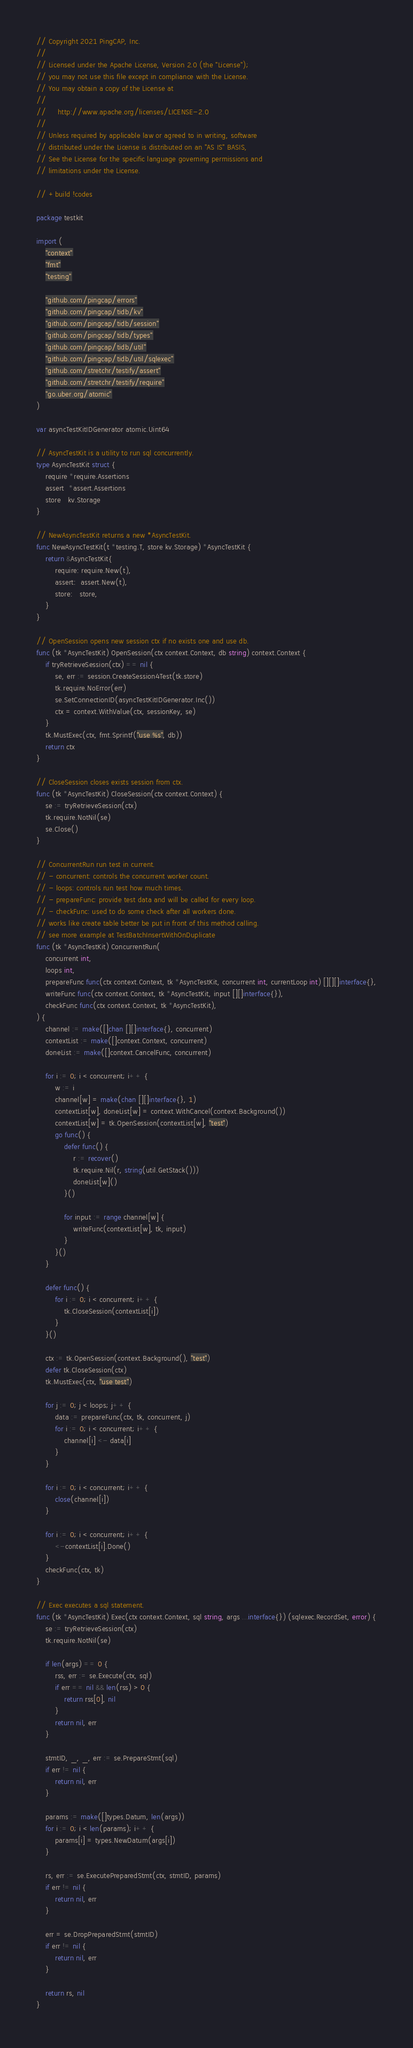Convert code to text. <code><loc_0><loc_0><loc_500><loc_500><_Go_>// Copyright 2021 PingCAP, Inc.
//
// Licensed under the Apache License, Version 2.0 (the "License");
// you may not use this file except in compliance with the License.
// You may obtain a copy of the License at
//
//     http://www.apache.org/licenses/LICENSE-2.0
//
// Unless required by applicable law or agreed to in writing, software
// distributed under the License is distributed on an "AS IS" BASIS,
// See the License for the specific language governing permissions and
// limitations under the License.

// +build !codes

package testkit

import (
	"context"
	"fmt"
	"testing"

	"github.com/pingcap/errors"
	"github.com/pingcap/tidb/kv"
	"github.com/pingcap/tidb/session"
	"github.com/pingcap/tidb/types"
	"github.com/pingcap/tidb/util"
	"github.com/pingcap/tidb/util/sqlexec"
	"github.com/stretchr/testify/assert"
	"github.com/stretchr/testify/require"
	"go.uber.org/atomic"
)

var asyncTestKitIDGenerator atomic.Uint64

// AsyncTestKit is a utility to run sql concurrently.
type AsyncTestKit struct {
	require *require.Assertions
	assert  *assert.Assertions
	store   kv.Storage
}

// NewAsyncTestKit returns a new *AsyncTestKit.
func NewAsyncTestKit(t *testing.T, store kv.Storage) *AsyncTestKit {
	return &AsyncTestKit{
		require: require.New(t),
		assert:  assert.New(t),
		store:   store,
	}
}

// OpenSession opens new session ctx if no exists one and use db.
func (tk *AsyncTestKit) OpenSession(ctx context.Context, db string) context.Context {
	if tryRetrieveSession(ctx) == nil {
		se, err := session.CreateSession4Test(tk.store)
		tk.require.NoError(err)
		se.SetConnectionID(asyncTestKitIDGenerator.Inc())
		ctx = context.WithValue(ctx, sessionKey, se)
	}
	tk.MustExec(ctx, fmt.Sprintf("use %s", db))
	return ctx
}

// CloseSession closes exists session from ctx.
func (tk *AsyncTestKit) CloseSession(ctx context.Context) {
	se := tryRetrieveSession(ctx)
	tk.require.NotNil(se)
	se.Close()
}

// ConcurrentRun run test in current.
// - concurrent: controls the concurrent worker count.
// - loops: controls run test how much times.
// - prepareFunc: provide test data and will be called for every loop.
// - checkFunc: used to do some check after all workers done.
// works like create table better be put in front of this method calling.
// see more example at TestBatchInsertWithOnDuplicate
func (tk *AsyncTestKit) ConcurrentRun(
	concurrent int,
	loops int,
	prepareFunc func(ctx context.Context, tk *AsyncTestKit, concurrent int, currentLoop int) [][][]interface{},
	writeFunc func(ctx context.Context, tk *AsyncTestKit, input [][]interface{}),
	checkFunc func(ctx context.Context, tk *AsyncTestKit),
) {
	channel := make([]chan [][]interface{}, concurrent)
	contextList := make([]context.Context, concurrent)
	doneList := make([]context.CancelFunc, concurrent)

	for i := 0; i < concurrent; i++ {
		w := i
		channel[w] = make(chan [][]interface{}, 1)
		contextList[w], doneList[w] = context.WithCancel(context.Background())
		contextList[w] = tk.OpenSession(contextList[w], "test")
		go func() {
			defer func() {
				r := recover()
				tk.require.Nil(r, string(util.GetStack()))
				doneList[w]()
			}()

			for input := range channel[w] {
				writeFunc(contextList[w], tk, input)
			}
		}()
	}

	defer func() {
		for i := 0; i < concurrent; i++ {
			tk.CloseSession(contextList[i])
		}
	}()

	ctx := tk.OpenSession(context.Background(), "test")
	defer tk.CloseSession(ctx)
	tk.MustExec(ctx, "use test")

	for j := 0; j < loops; j++ {
		data := prepareFunc(ctx, tk, concurrent, j)
		for i := 0; i < concurrent; i++ {
			channel[i] <- data[i]
		}
	}

	for i := 0; i < concurrent; i++ {
		close(channel[i])
	}

	for i := 0; i < concurrent; i++ {
		<-contextList[i].Done()
	}
	checkFunc(ctx, tk)
}

// Exec executes a sql statement.
func (tk *AsyncTestKit) Exec(ctx context.Context, sql string, args ...interface{}) (sqlexec.RecordSet, error) {
	se := tryRetrieveSession(ctx)
	tk.require.NotNil(se)

	if len(args) == 0 {
		rss, err := se.Execute(ctx, sql)
		if err == nil && len(rss) > 0 {
			return rss[0], nil
		}
		return nil, err
	}

	stmtID, _, _, err := se.PrepareStmt(sql)
	if err != nil {
		return nil, err
	}

	params := make([]types.Datum, len(args))
	for i := 0; i < len(params); i++ {
		params[i] = types.NewDatum(args[i])
	}

	rs, err := se.ExecutePreparedStmt(ctx, stmtID, params)
	if err != nil {
		return nil, err
	}

	err = se.DropPreparedStmt(stmtID)
	if err != nil {
		return nil, err
	}

	return rs, nil
}
</code> 